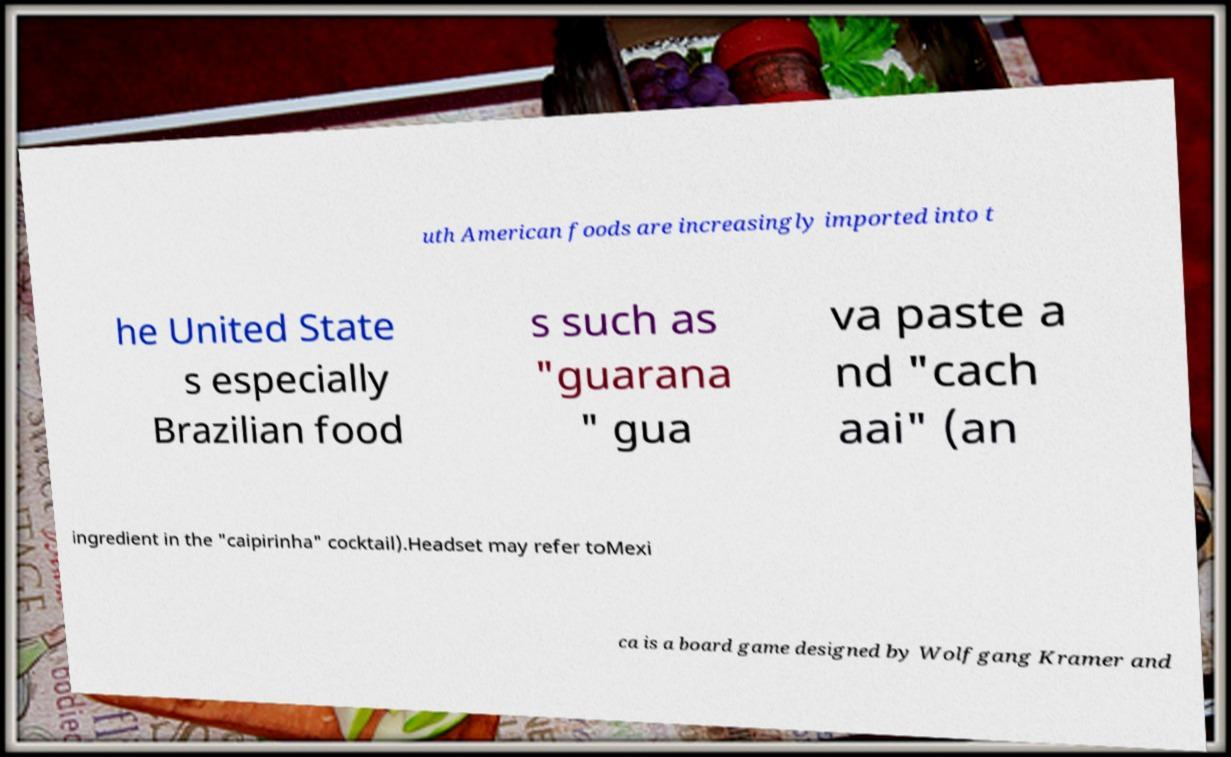Please read and relay the text visible in this image. What does it say? uth American foods are increasingly imported into t he United State s especially Brazilian food s such as "guarana " gua va paste a nd "cach aai" (an ingredient in the "caipirinha" cocktail).Headset may refer toMexi ca is a board game designed by Wolfgang Kramer and 